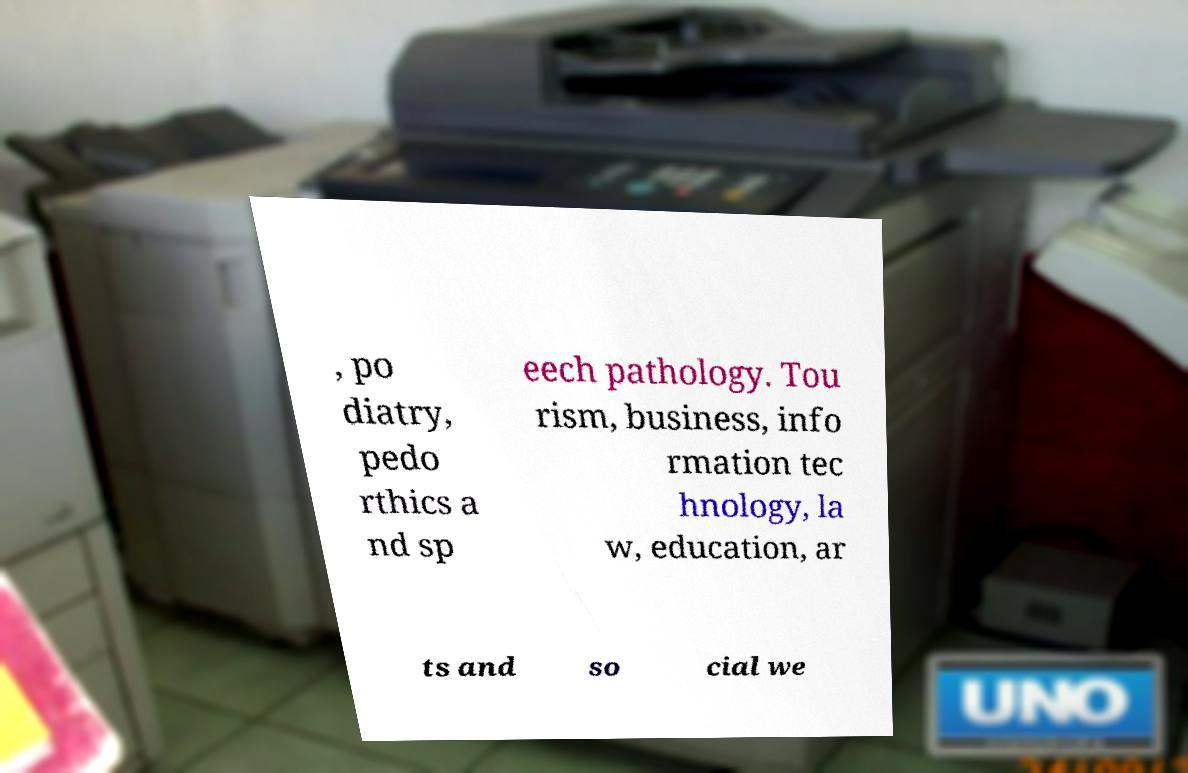Could you assist in decoding the text presented in this image and type it out clearly? , po diatry, pedo rthics a nd sp eech pathology. Tou rism, business, info rmation tec hnology, la w, education, ar ts and so cial we 